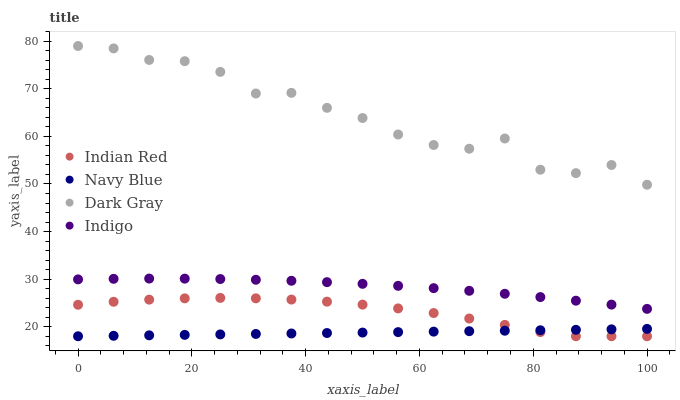Does Navy Blue have the minimum area under the curve?
Answer yes or no. Yes. Does Dark Gray have the maximum area under the curve?
Answer yes or no. Yes. Does Indigo have the minimum area under the curve?
Answer yes or no. No. Does Indigo have the maximum area under the curve?
Answer yes or no. No. Is Navy Blue the smoothest?
Answer yes or no. Yes. Is Dark Gray the roughest?
Answer yes or no. Yes. Is Indigo the smoothest?
Answer yes or no. No. Is Indigo the roughest?
Answer yes or no. No. Does Navy Blue have the lowest value?
Answer yes or no. Yes. Does Indigo have the lowest value?
Answer yes or no. No. Does Dark Gray have the highest value?
Answer yes or no. Yes. Does Indigo have the highest value?
Answer yes or no. No. Is Navy Blue less than Indigo?
Answer yes or no. Yes. Is Dark Gray greater than Indian Red?
Answer yes or no. Yes. Does Indian Red intersect Navy Blue?
Answer yes or no. Yes. Is Indian Red less than Navy Blue?
Answer yes or no. No. Is Indian Red greater than Navy Blue?
Answer yes or no. No. Does Navy Blue intersect Indigo?
Answer yes or no. No. 